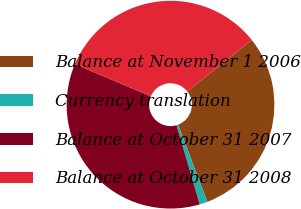Convert chart to OTSL. <chart><loc_0><loc_0><loc_500><loc_500><pie_chart><fcel>Balance at November 1 2006<fcel>Currency translation<fcel>Balance at October 31 2007<fcel>Balance at October 31 2008<nl><fcel>29.93%<fcel>1.23%<fcel>35.92%<fcel>32.92%<nl></chart> 